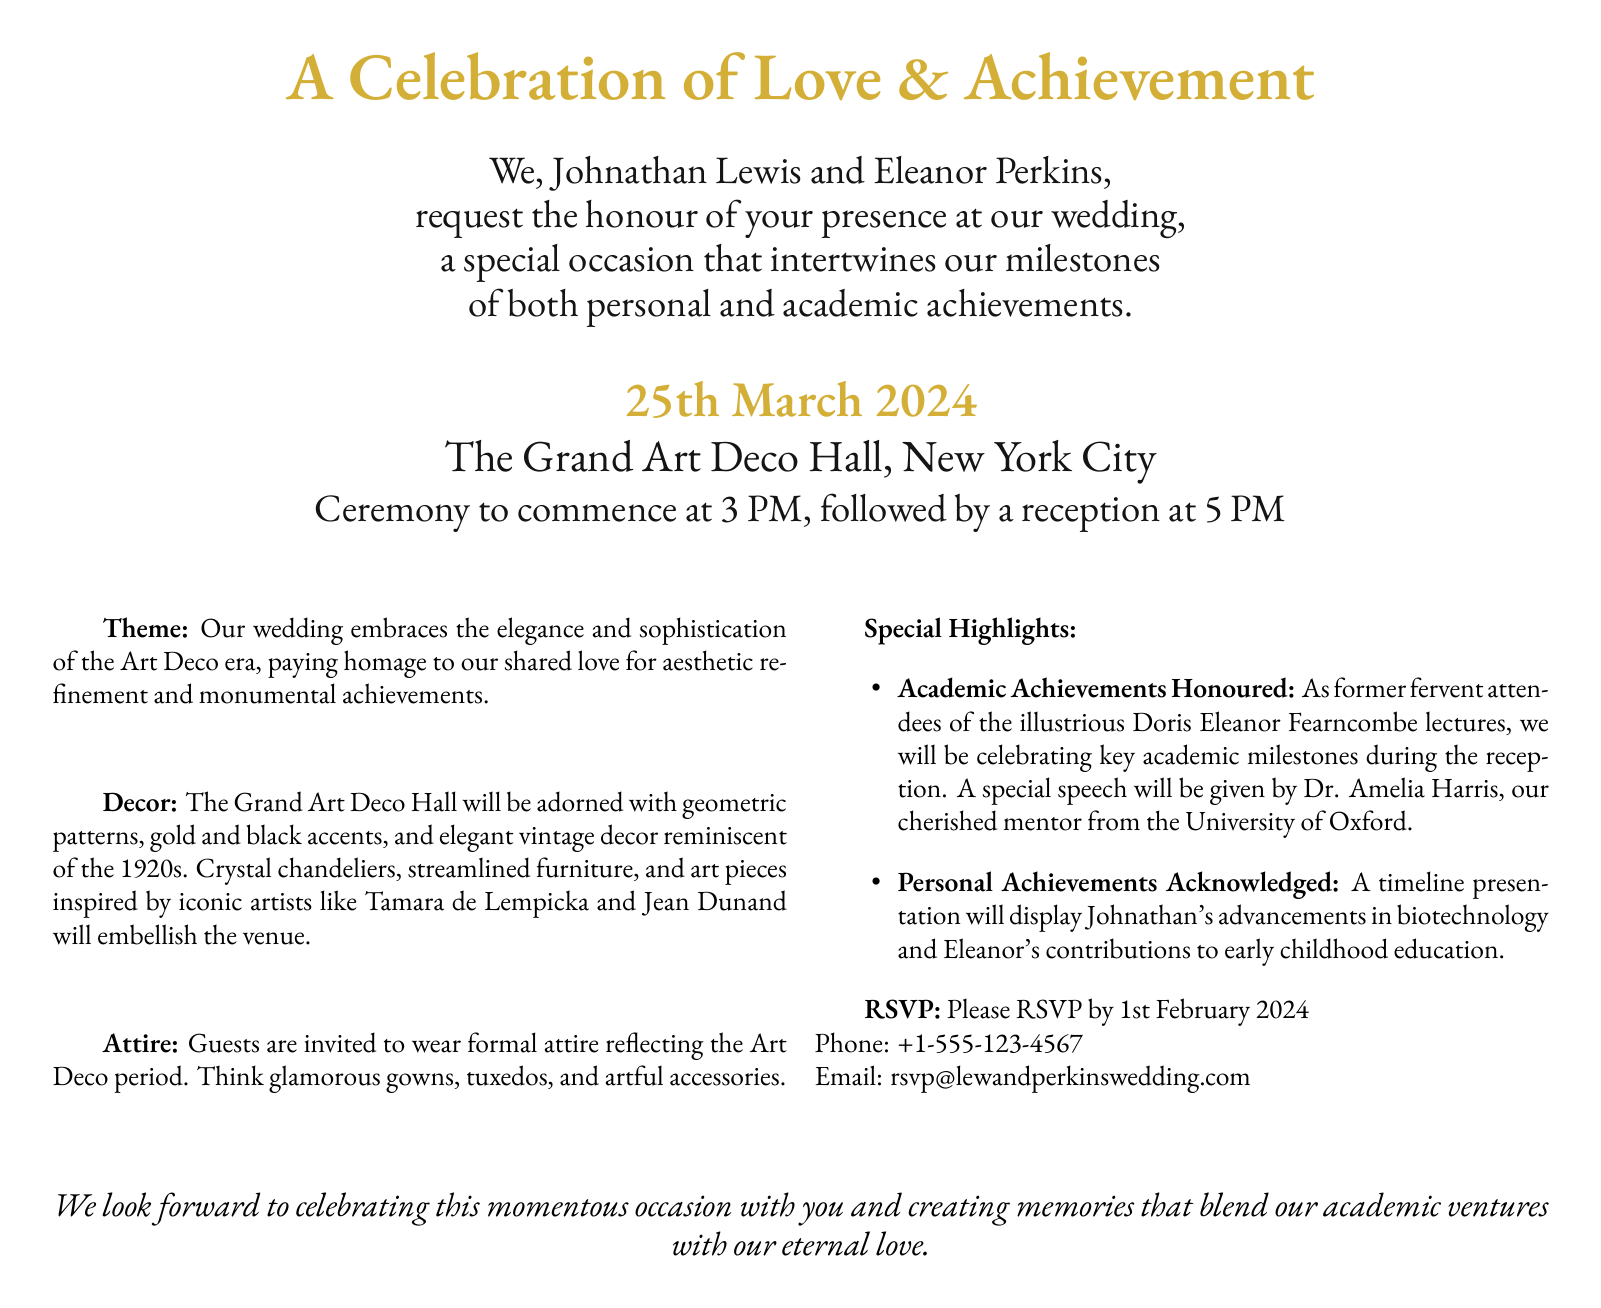What is the date of the wedding? The wedding date is specifically mentioned in the document, listed clearly.
Answer: 25th March 2024 Where is the wedding ceremony taking place? The invitation indicates the location of the wedding ceremony.
Answer: The Grand Art Deco Hall, New York City Who are the hosts of the wedding? The names of the individuals hosting the wedding are mentioned prominently.
Answer: Johnathan Lewis and Eleanor Perkins What time does the ceremony start? The document specifies the starting time of the ceremony.
Answer: 3 PM What is the theme of the wedding? The theme is briefly outlined in the document.
Answer: Art Deco Who will give a special speech at the reception? The document mentions a specific individual who is scheduled to speak.
Answer: Dr. Amelia Harris What are guests invited to wear? The attire for guests is described in the document.
Answer: Formal attire reflecting the Art Deco period What academic achievements are being honored? The invitation notes that certain academic milestones will be acknowledged during the event.
Answer: Key academic milestones When is the RSVP deadline? The document clearly states the date by which RSVPs should be returned.
Answer: 1st February 2024 